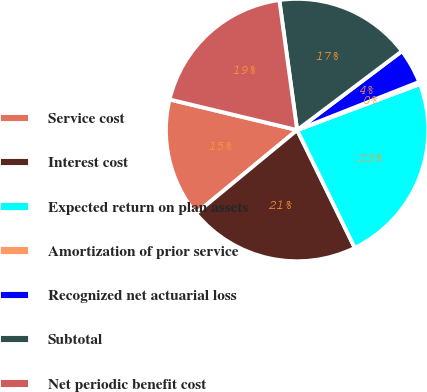Convert chart. <chart><loc_0><loc_0><loc_500><loc_500><pie_chart><fcel>Service cost<fcel>Interest cost<fcel>Expected return on plan assets<fcel>Amortization of prior service<fcel>Recognized net actuarial loss<fcel>Subtotal<fcel>Net periodic benefit cost<nl><fcel>14.72%<fcel>21.27%<fcel>23.46%<fcel>0.28%<fcel>4.29%<fcel>16.9%<fcel>19.09%<nl></chart> 